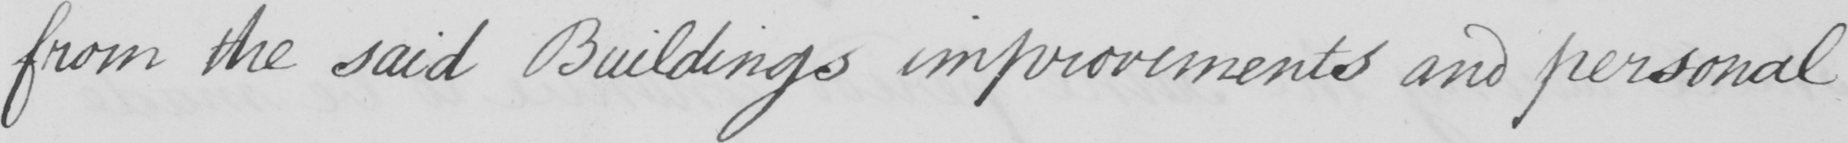Please transcribe the handwritten text in this image. from the said Buildings improvements and personal 